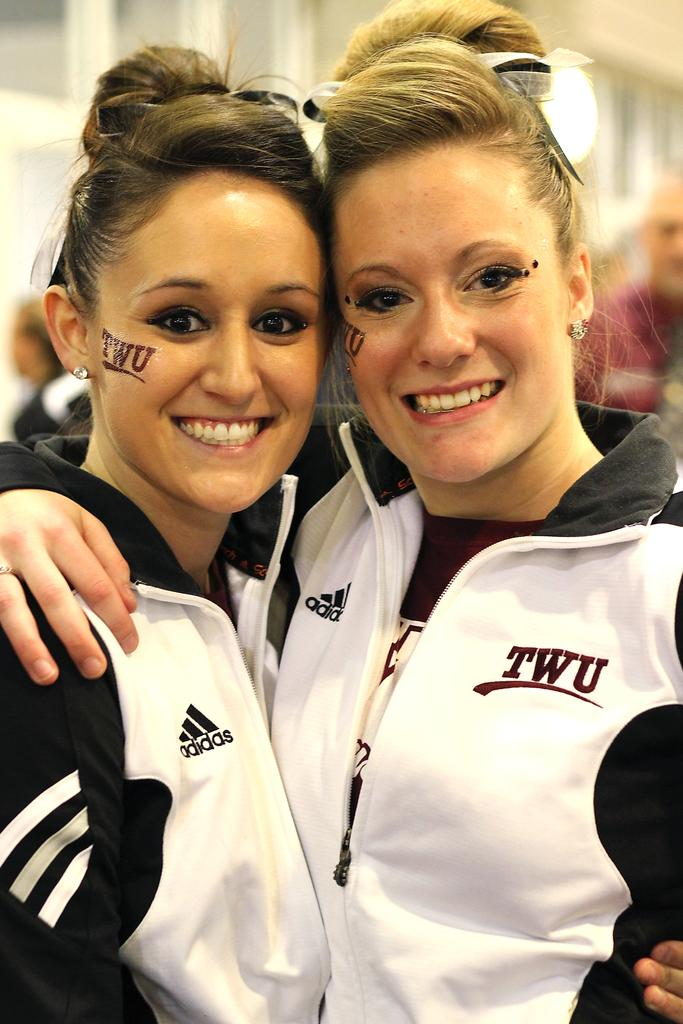<image>
Relay a brief, clear account of the picture shown. Two pony-tailed TWU students smile at the camera. 